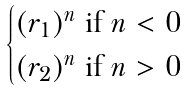<formula> <loc_0><loc_0><loc_500><loc_500>\begin{cases} ( r _ { 1 } ) ^ { n } \text { if } n < 0 \\ ( r _ { 2 } ) ^ { n } \text { if } n > 0 \end{cases}</formula> 